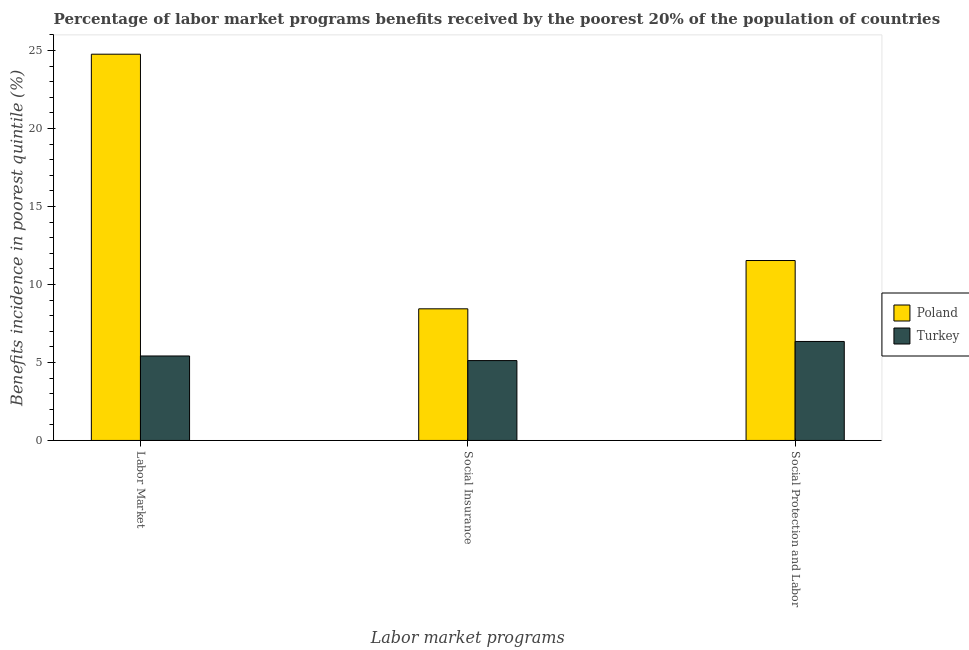How many bars are there on the 2nd tick from the left?
Your answer should be compact. 2. What is the label of the 1st group of bars from the left?
Keep it short and to the point. Labor Market. What is the percentage of benefits received due to labor market programs in Turkey?
Offer a terse response. 5.42. Across all countries, what is the maximum percentage of benefits received due to labor market programs?
Your response must be concise. 24.76. Across all countries, what is the minimum percentage of benefits received due to social protection programs?
Offer a terse response. 6.35. In which country was the percentage of benefits received due to social insurance programs maximum?
Give a very brief answer. Poland. What is the total percentage of benefits received due to social protection programs in the graph?
Make the answer very short. 17.88. What is the difference between the percentage of benefits received due to labor market programs in Poland and that in Turkey?
Give a very brief answer. 19.35. What is the difference between the percentage of benefits received due to social protection programs in Poland and the percentage of benefits received due to labor market programs in Turkey?
Your answer should be very brief. 6.12. What is the average percentage of benefits received due to social insurance programs per country?
Your answer should be compact. 6.78. What is the difference between the percentage of benefits received due to labor market programs and percentage of benefits received due to social insurance programs in Poland?
Offer a very short reply. 16.32. What is the ratio of the percentage of benefits received due to social insurance programs in Turkey to that in Poland?
Your answer should be compact. 0.61. Is the percentage of benefits received due to social insurance programs in Poland less than that in Turkey?
Give a very brief answer. No. Is the difference between the percentage of benefits received due to social protection programs in Turkey and Poland greater than the difference between the percentage of benefits received due to social insurance programs in Turkey and Poland?
Keep it short and to the point. No. What is the difference between the highest and the second highest percentage of benefits received due to labor market programs?
Your answer should be compact. 19.35. What is the difference between the highest and the lowest percentage of benefits received due to social protection programs?
Provide a succinct answer. 5.19. In how many countries, is the percentage of benefits received due to social insurance programs greater than the average percentage of benefits received due to social insurance programs taken over all countries?
Keep it short and to the point. 1. Is the sum of the percentage of benefits received due to social insurance programs in Poland and Turkey greater than the maximum percentage of benefits received due to labor market programs across all countries?
Your answer should be compact. No. What does the 2nd bar from the left in Social Insurance represents?
Give a very brief answer. Turkey. What does the 2nd bar from the right in Social Insurance represents?
Your answer should be very brief. Poland. Is it the case that in every country, the sum of the percentage of benefits received due to labor market programs and percentage of benefits received due to social insurance programs is greater than the percentage of benefits received due to social protection programs?
Provide a succinct answer. Yes. How many bars are there?
Your answer should be compact. 6. How many countries are there in the graph?
Offer a very short reply. 2. What is the difference between two consecutive major ticks on the Y-axis?
Provide a succinct answer. 5. Does the graph contain any zero values?
Provide a succinct answer. No. Does the graph contain grids?
Provide a succinct answer. No. How are the legend labels stacked?
Ensure brevity in your answer.  Vertical. What is the title of the graph?
Make the answer very short. Percentage of labor market programs benefits received by the poorest 20% of the population of countries. What is the label or title of the X-axis?
Provide a short and direct response. Labor market programs. What is the label or title of the Y-axis?
Offer a very short reply. Benefits incidence in poorest quintile (%). What is the Benefits incidence in poorest quintile (%) of Poland in Labor Market?
Give a very brief answer. 24.76. What is the Benefits incidence in poorest quintile (%) of Turkey in Labor Market?
Keep it short and to the point. 5.42. What is the Benefits incidence in poorest quintile (%) in Poland in Social Insurance?
Your answer should be very brief. 8.44. What is the Benefits incidence in poorest quintile (%) in Turkey in Social Insurance?
Your answer should be compact. 5.12. What is the Benefits incidence in poorest quintile (%) in Poland in Social Protection and Labor?
Your answer should be compact. 11.54. What is the Benefits incidence in poorest quintile (%) of Turkey in Social Protection and Labor?
Keep it short and to the point. 6.35. Across all Labor market programs, what is the maximum Benefits incidence in poorest quintile (%) of Poland?
Your response must be concise. 24.76. Across all Labor market programs, what is the maximum Benefits incidence in poorest quintile (%) in Turkey?
Keep it short and to the point. 6.35. Across all Labor market programs, what is the minimum Benefits incidence in poorest quintile (%) in Poland?
Give a very brief answer. 8.44. Across all Labor market programs, what is the minimum Benefits incidence in poorest quintile (%) of Turkey?
Your answer should be very brief. 5.12. What is the total Benefits incidence in poorest quintile (%) of Poland in the graph?
Your answer should be very brief. 44.74. What is the total Benefits incidence in poorest quintile (%) in Turkey in the graph?
Offer a very short reply. 16.88. What is the difference between the Benefits incidence in poorest quintile (%) in Poland in Labor Market and that in Social Insurance?
Provide a succinct answer. 16.32. What is the difference between the Benefits incidence in poorest quintile (%) in Turkey in Labor Market and that in Social Insurance?
Make the answer very short. 0.3. What is the difference between the Benefits incidence in poorest quintile (%) in Poland in Labor Market and that in Social Protection and Labor?
Your answer should be compact. 13.23. What is the difference between the Benefits incidence in poorest quintile (%) in Turkey in Labor Market and that in Social Protection and Labor?
Your answer should be very brief. -0.93. What is the difference between the Benefits incidence in poorest quintile (%) in Poland in Social Insurance and that in Social Protection and Labor?
Provide a short and direct response. -3.1. What is the difference between the Benefits incidence in poorest quintile (%) in Turkey in Social Insurance and that in Social Protection and Labor?
Give a very brief answer. -1.23. What is the difference between the Benefits incidence in poorest quintile (%) of Poland in Labor Market and the Benefits incidence in poorest quintile (%) of Turkey in Social Insurance?
Provide a short and direct response. 19.64. What is the difference between the Benefits incidence in poorest quintile (%) of Poland in Labor Market and the Benefits incidence in poorest quintile (%) of Turkey in Social Protection and Labor?
Offer a very short reply. 18.42. What is the difference between the Benefits incidence in poorest quintile (%) in Poland in Social Insurance and the Benefits incidence in poorest quintile (%) in Turkey in Social Protection and Labor?
Your answer should be compact. 2.09. What is the average Benefits incidence in poorest quintile (%) of Poland per Labor market programs?
Provide a short and direct response. 14.91. What is the average Benefits incidence in poorest quintile (%) in Turkey per Labor market programs?
Offer a very short reply. 5.63. What is the difference between the Benefits incidence in poorest quintile (%) of Poland and Benefits incidence in poorest quintile (%) of Turkey in Labor Market?
Provide a short and direct response. 19.35. What is the difference between the Benefits incidence in poorest quintile (%) in Poland and Benefits incidence in poorest quintile (%) in Turkey in Social Insurance?
Provide a short and direct response. 3.32. What is the difference between the Benefits incidence in poorest quintile (%) in Poland and Benefits incidence in poorest quintile (%) in Turkey in Social Protection and Labor?
Make the answer very short. 5.19. What is the ratio of the Benefits incidence in poorest quintile (%) in Poland in Labor Market to that in Social Insurance?
Give a very brief answer. 2.93. What is the ratio of the Benefits incidence in poorest quintile (%) of Turkey in Labor Market to that in Social Insurance?
Your answer should be compact. 1.06. What is the ratio of the Benefits incidence in poorest quintile (%) of Poland in Labor Market to that in Social Protection and Labor?
Give a very brief answer. 2.15. What is the ratio of the Benefits incidence in poorest quintile (%) in Turkey in Labor Market to that in Social Protection and Labor?
Keep it short and to the point. 0.85. What is the ratio of the Benefits incidence in poorest quintile (%) of Poland in Social Insurance to that in Social Protection and Labor?
Offer a terse response. 0.73. What is the ratio of the Benefits incidence in poorest quintile (%) in Turkey in Social Insurance to that in Social Protection and Labor?
Your answer should be very brief. 0.81. What is the difference between the highest and the second highest Benefits incidence in poorest quintile (%) in Poland?
Provide a short and direct response. 13.23. What is the difference between the highest and the second highest Benefits incidence in poorest quintile (%) in Turkey?
Ensure brevity in your answer.  0.93. What is the difference between the highest and the lowest Benefits incidence in poorest quintile (%) of Poland?
Your response must be concise. 16.32. What is the difference between the highest and the lowest Benefits incidence in poorest quintile (%) of Turkey?
Provide a short and direct response. 1.23. 